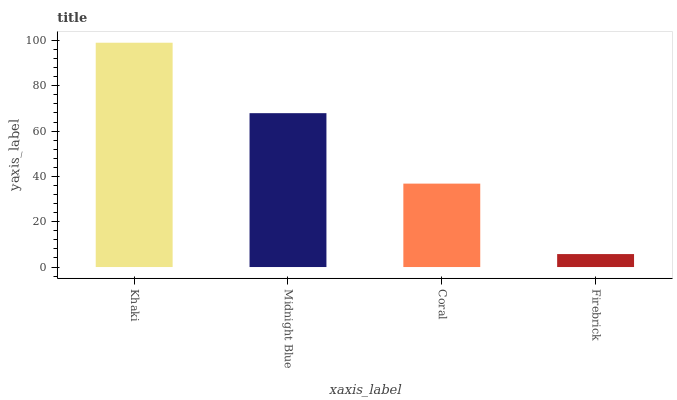Is Firebrick the minimum?
Answer yes or no. Yes. Is Khaki the maximum?
Answer yes or no. Yes. Is Midnight Blue the minimum?
Answer yes or no. No. Is Midnight Blue the maximum?
Answer yes or no. No. Is Khaki greater than Midnight Blue?
Answer yes or no. Yes. Is Midnight Blue less than Khaki?
Answer yes or no. Yes. Is Midnight Blue greater than Khaki?
Answer yes or no. No. Is Khaki less than Midnight Blue?
Answer yes or no. No. Is Midnight Blue the high median?
Answer yes or no. Yes. Is Coral the low median?
Answer yes or no. Yes. Is Khaki the high median?
Answer yes or no. No. Is Midnight Blue the low median?
Answer yes or no. No. 